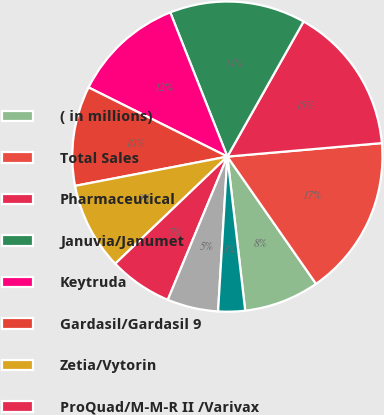Convert chart. <chart><loc_0><loc_0><loc_500><loc_500><pie_chart><fcel>( in millions)<fcel>Total Sales<fcel>Pharmaceutical<fcel>Januvia/Janumet<fcel>Keytruda<fcel>Gardasil/Gardasil 9<fcel>Zetia/Vytorin<fcel>ProQuad/M-M-R II /Varivax<fcel>Isentress/Isentress HD<fcel>Remicade<nl><fcel>7.85%<fcel>16.7%<fcel>15.44%<fcel>14.17%<fcel>11.64%<fcel>10.38%<fcel>9.11%<fcel>6.59%<fcel>5.32%<fcel>2.79%<nl></chart> 